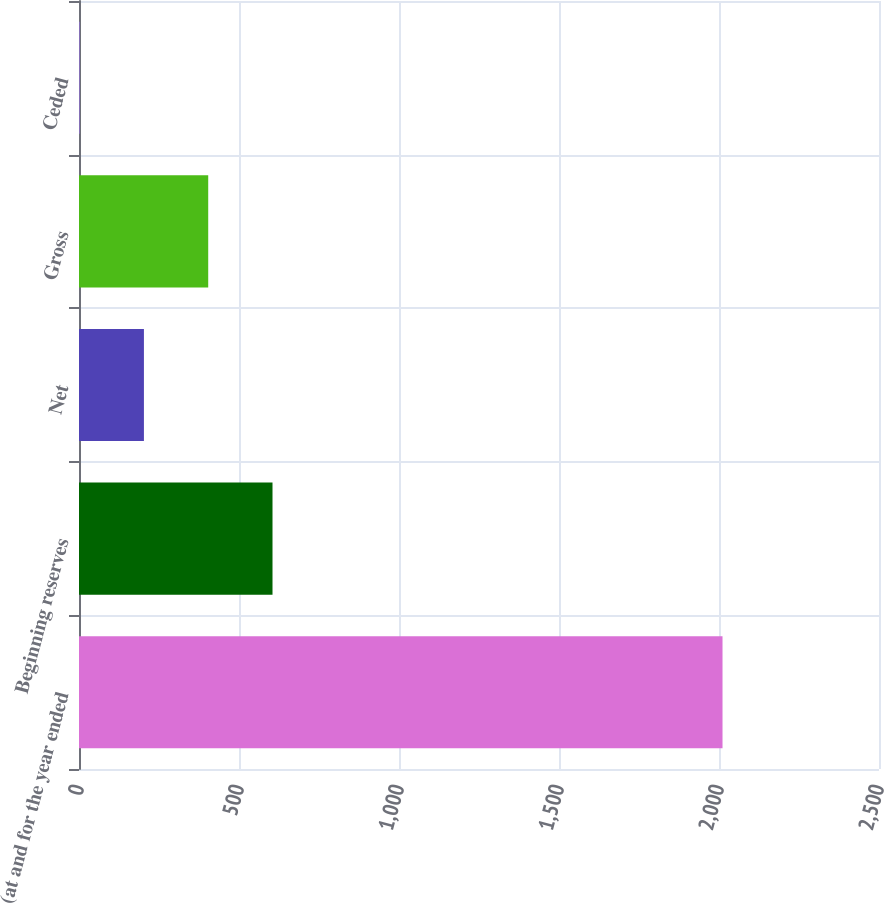Convert chart. <chart><loc_0><loc_0><loc_500><loc_500><bar_chart><fcel>(at and for the year ended<fcel>Beginning reserves<fcel>Net<fcel>Gross<fcel>Ceded<nl><fcel>2011<fcel>604.7<fcel>202.9<fcel>403.8<fcel>2<nl></chart> 